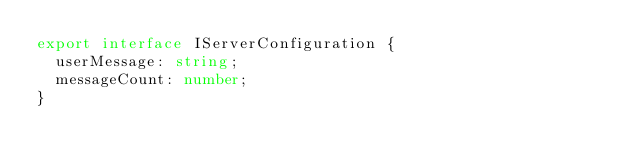<code> <loc_0><loc_0><loc_500><loc_500><_TypeScript_>export interface IServerConfiguration {
  userMessage: string;
  messageCount: number;
}
</code> 